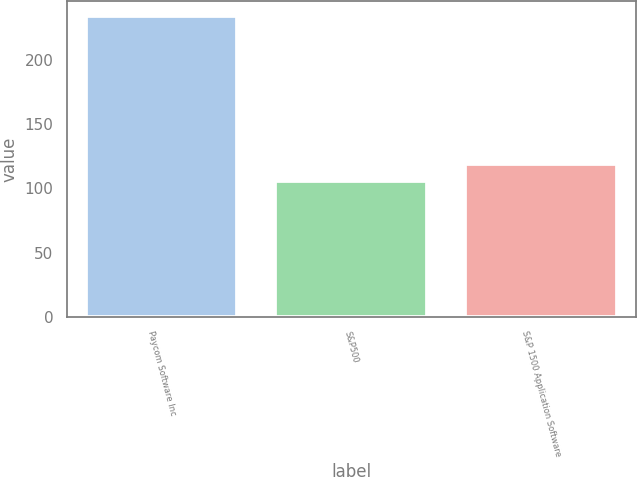<chart> <loc_0><loc_0><loc_500><loc_500><bar_chart><fcel>Paycom Software Inc<fcel>S&P500<fcel>S&P 1500 Application Software<nl><fcel>233.94<fcel>105.77<fcel>119.31<nl></chart> 